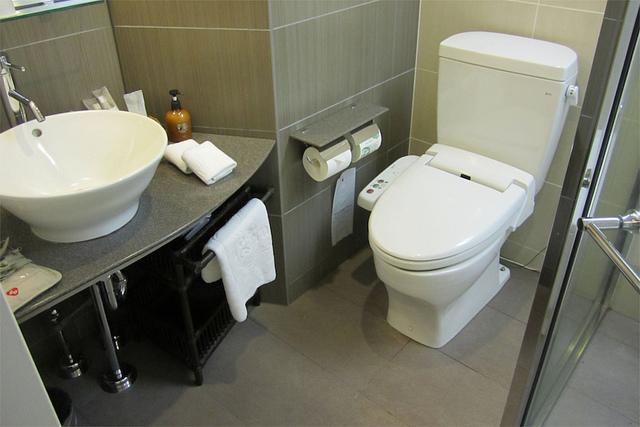What do the buttons to the right of the tissue rolls control? bidet 